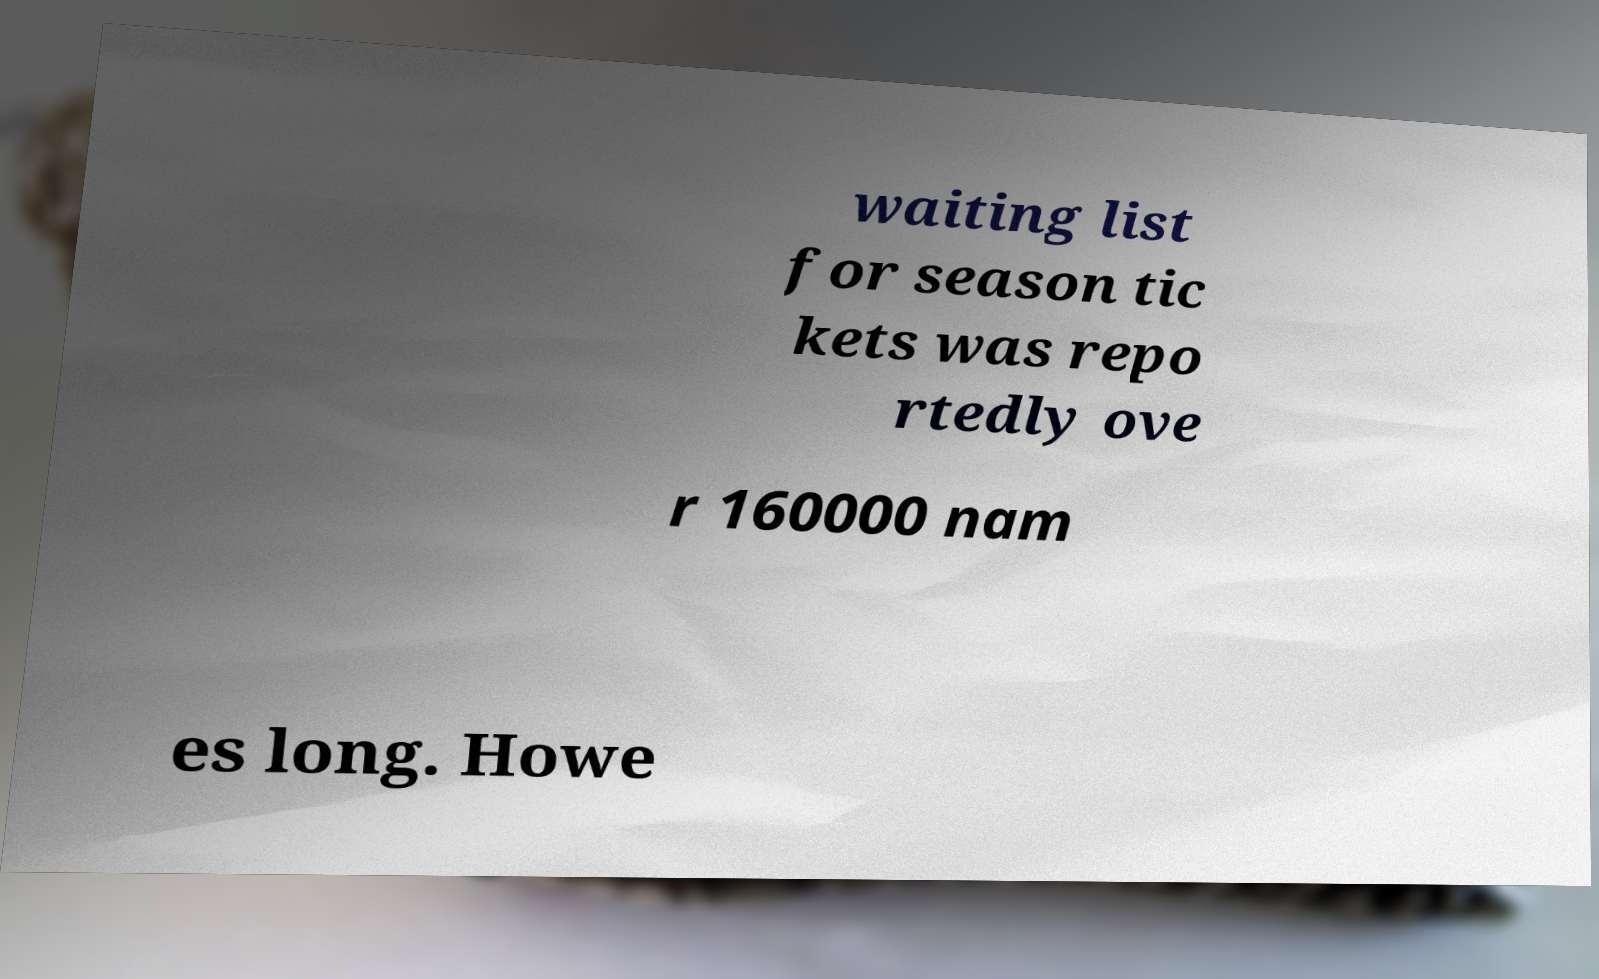Please read and relay the text visible in this image. What does it say? waiting list for season tic kets was repo rtedly ove r 160000 nam es long. Howe 